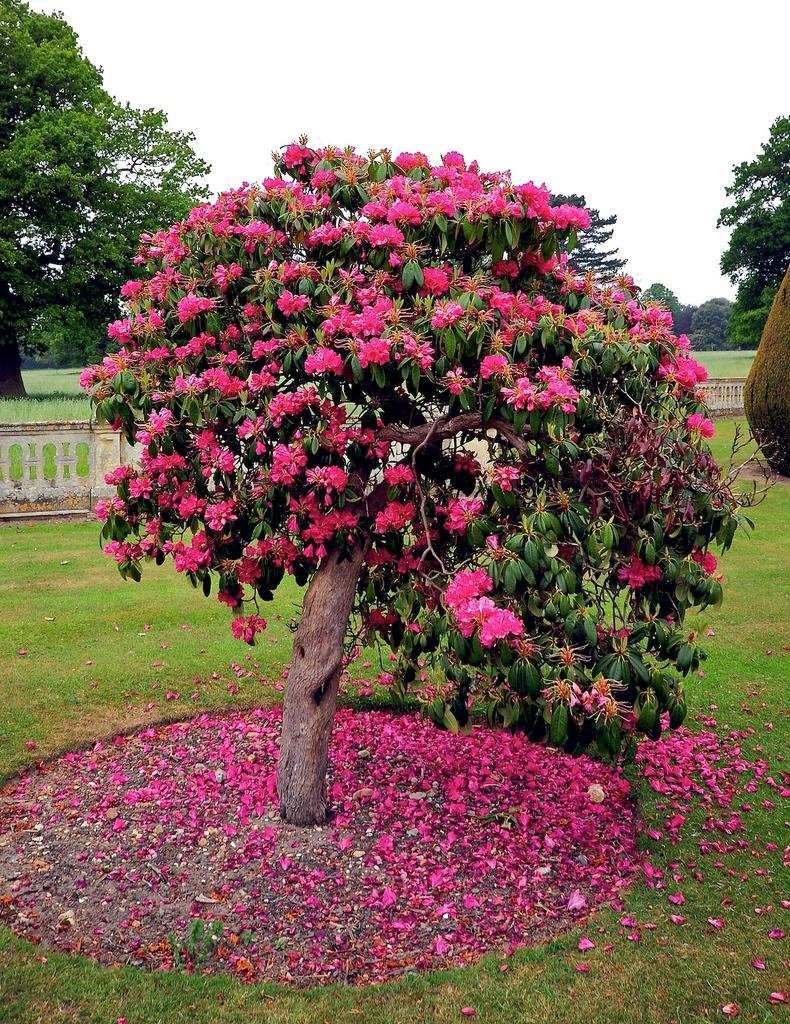What type of plant can be seen in the image? There is a tree in the image. What is special about the tree in the image? There are flowers on the tree. What can be found on the ground beneath the tree? Flower petals are on the ground. What type of vegetation covers the ground in the image? The ground is covered with grass. What is visible at the top of the image? The sky is clear and visible at the top of the image. What type of account is being discussed in the image? There is no account being discussed in the image; it features a tree with flowers and a clear sky. In which direction is the tree facing in the image? The image does not provide information about the direction the tree is facing; it only shows the tree, flowers, and sky. 